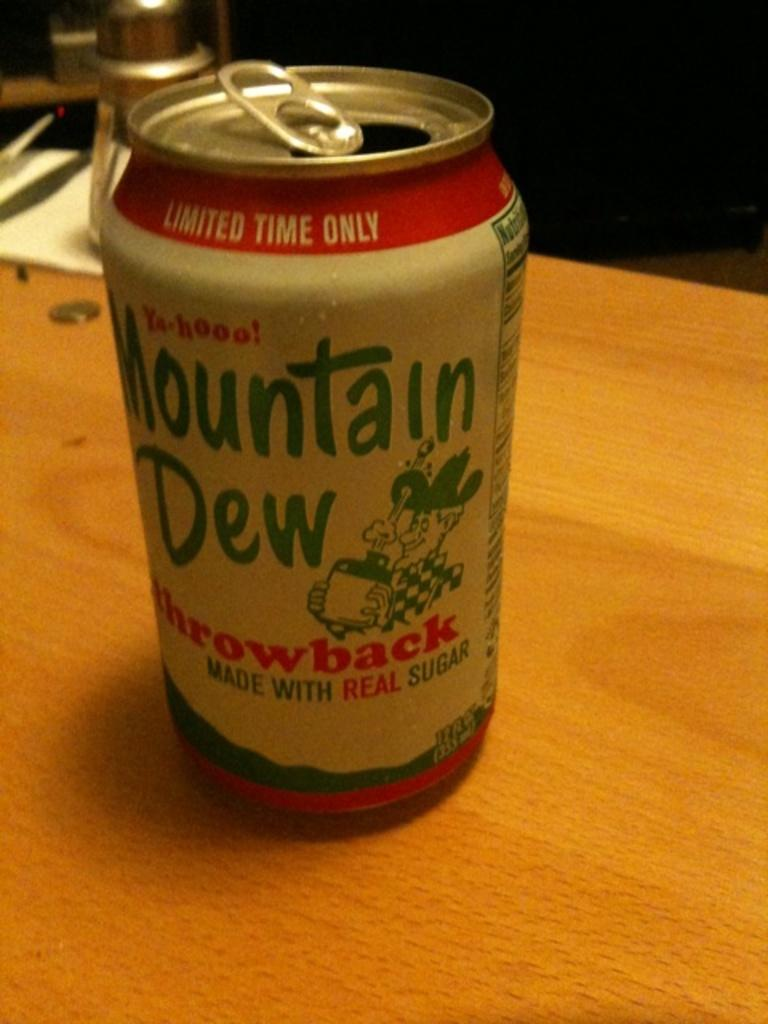<image>
Present a compact description of the photo's key features. A can of Mountain Dew says "throwback" on it. 